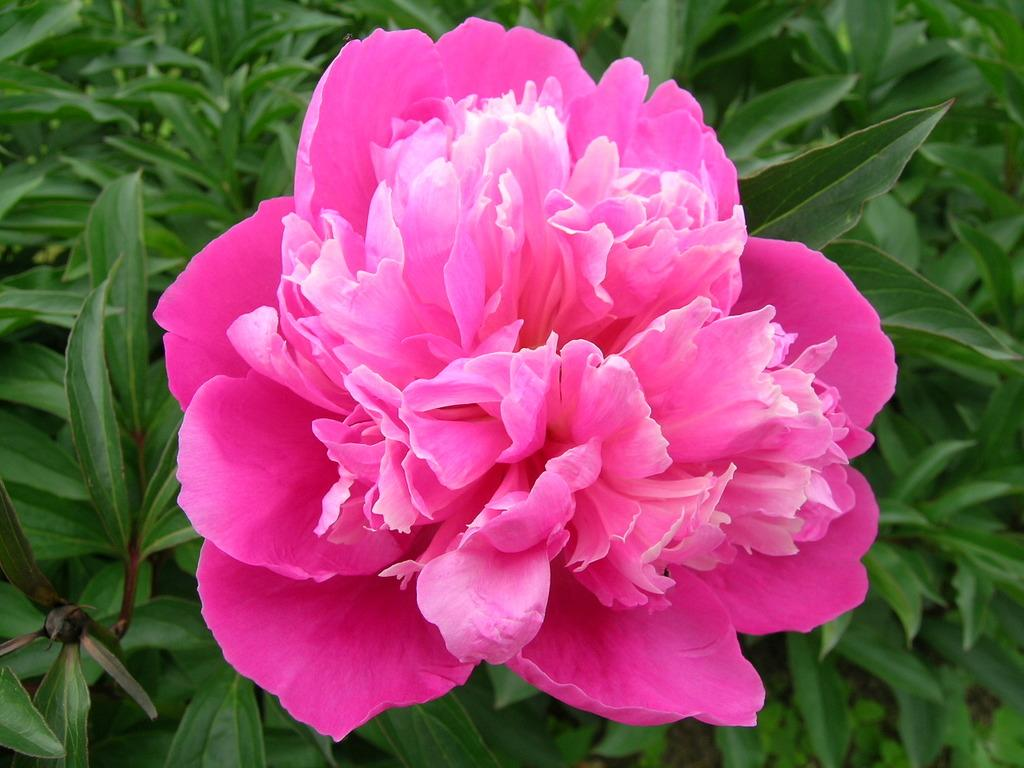What is the main subject of the image? The main subject of the image is a pink color flower. Can you describe the flower in the image? The pink color flower is located in the middle of the image. What else can be seen in the image besides the flower? There are green leaves in the image. What type of truck can be seen driving through the flower in the image? There is no truck present in the image; it features a pink color flower and green leaves. How many ghosts are visible interacting with the flower in the image? There are no ghosts present in the image; it features a pink color flower and green leaves. 